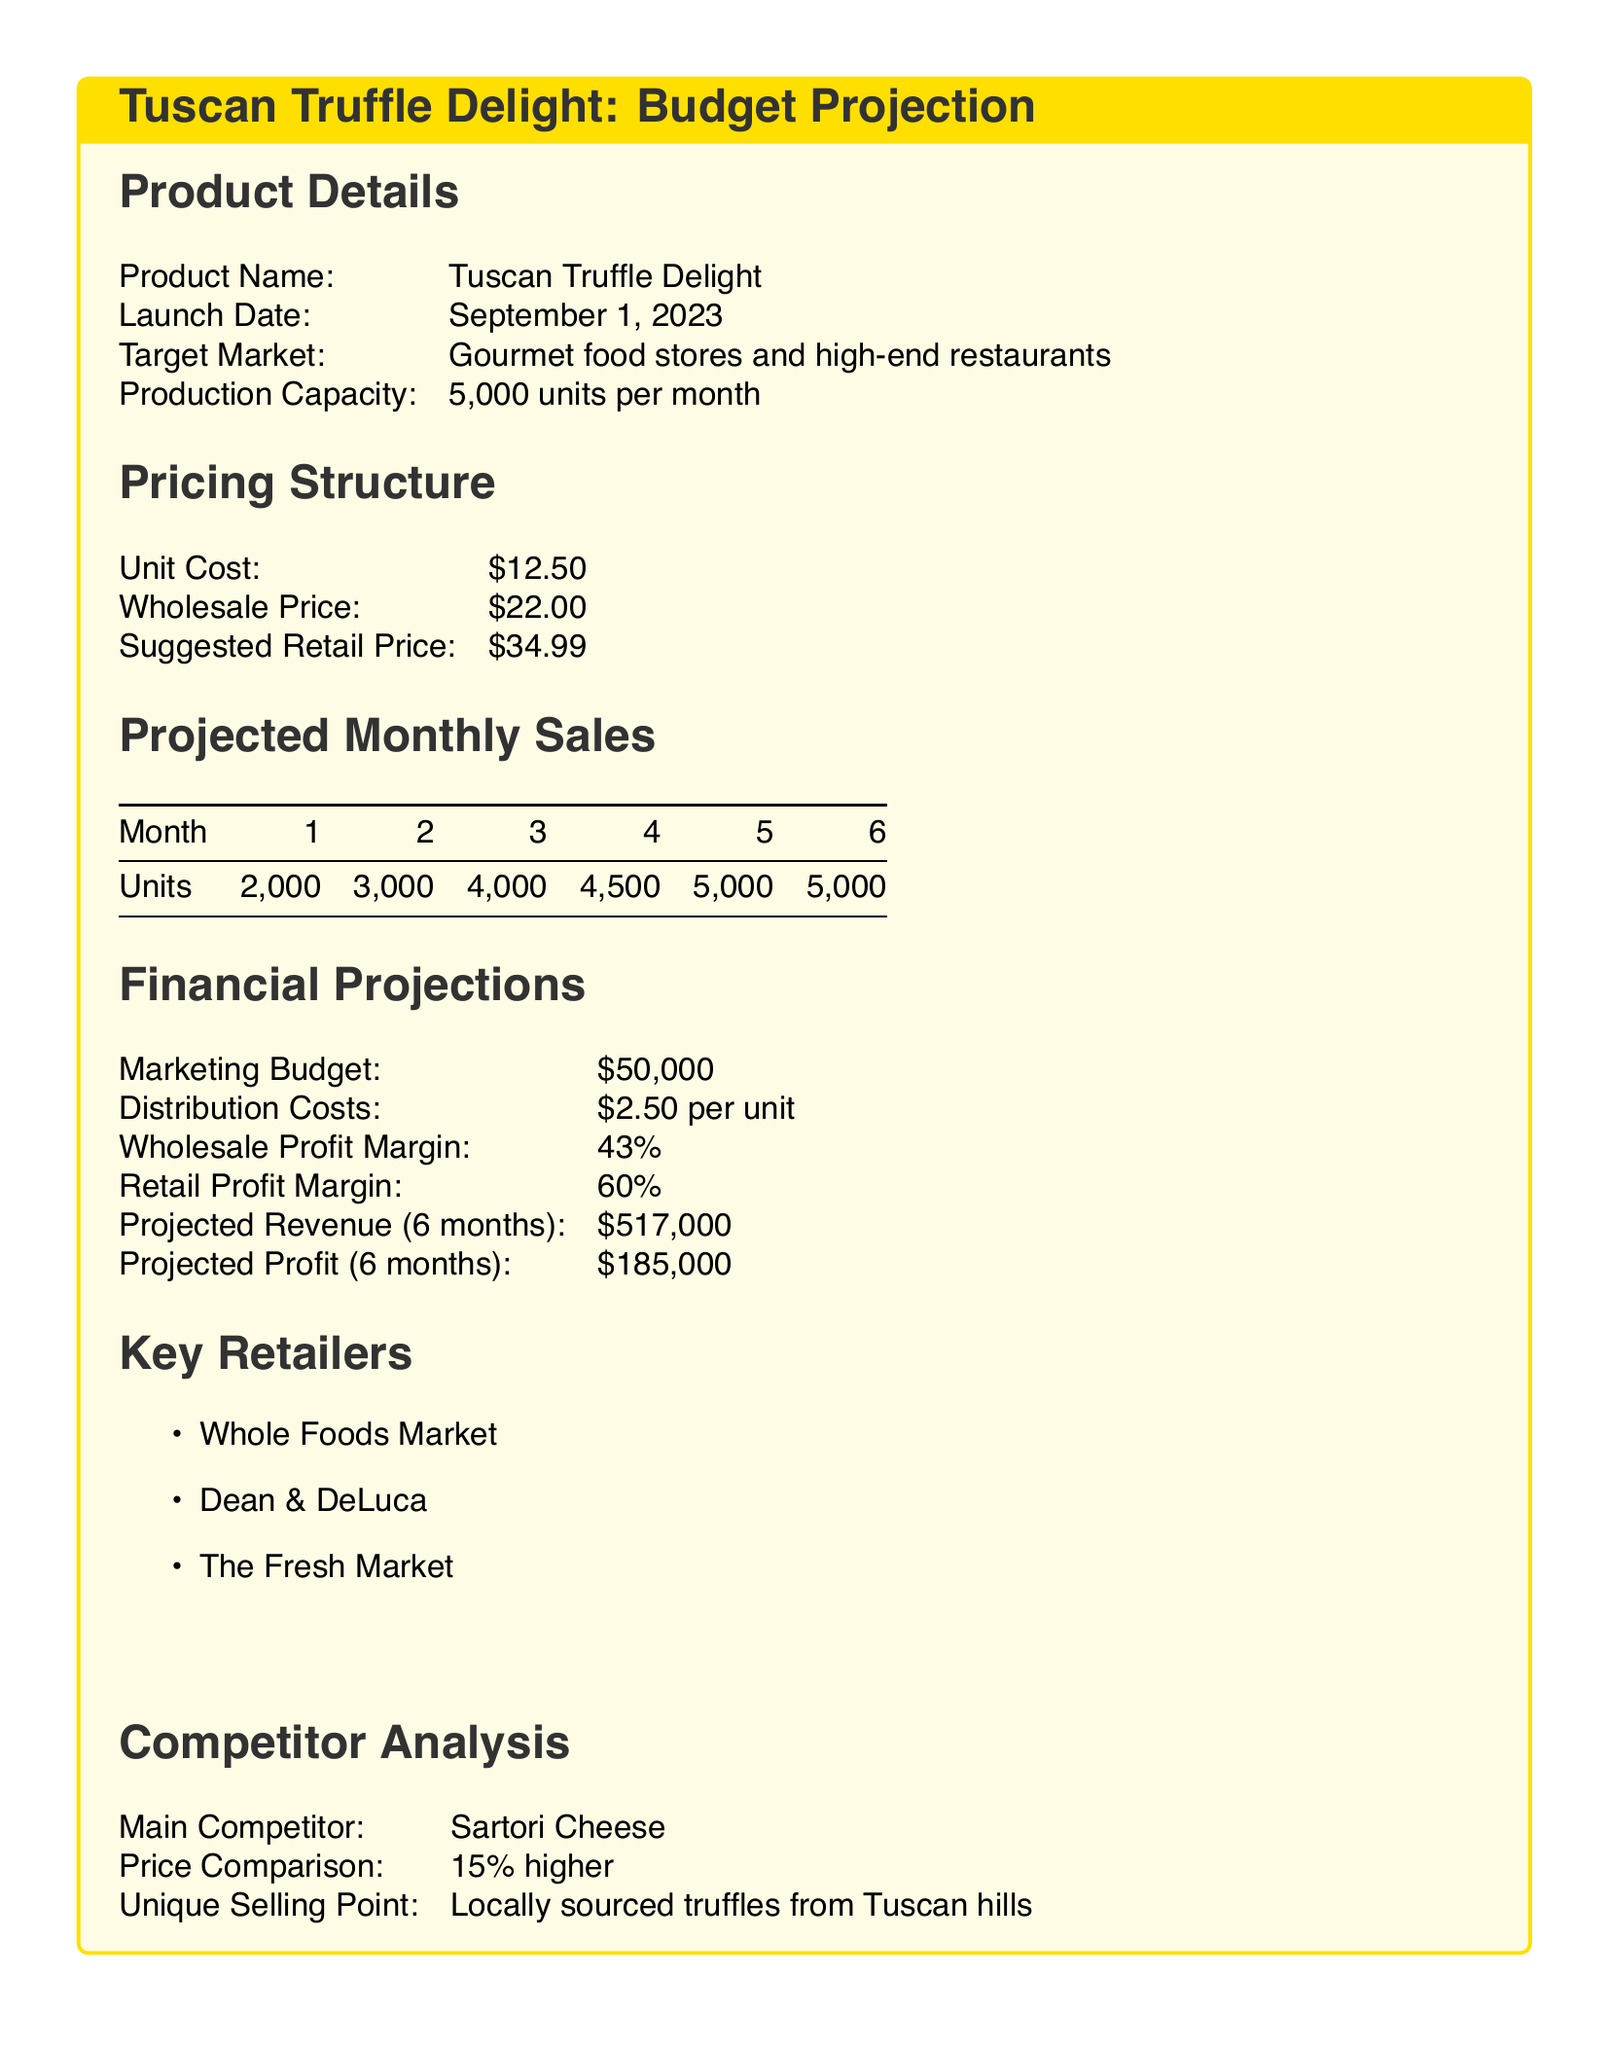What is the product name? The product name is stated clearly in the document as 'Tuscan Truffle Delight'.
Answer: Tuscan Truffle Delight When is the launch date? The launch date is specified in the document.
Answer: September 1, 2023 What is the production capacity per month? The document indicates the monthly production capacity.
Answer: 5,000 units What is the wholesale price? The document lists the wholesale price of the product.
Answer: $22.00 What is the total projected revenue for 6 months? The document specifies the total projected revenue for the first six months.
Answer: $517,000 What is the marketing budget? The marketing budget is detailed in the financial projections section.
Answer: $50,000 Which retailer is mentioned as a key retailer? The document lists key retailers and one of them can be identified.
Answer: Whole Foods Market What is the unique selling point of the product? The document describes the unique selling point in the competitor analysis.
Answer: Locally sourced truffles from Tuscan hills What is the retail profit margin? The profit margin for retail sales is provided in the financial projections.
Answer: 60% How does the product's price compare to its main competitor? The document provides a comparison between the product's price and that of the main competitor.
Answer: 15% higher 